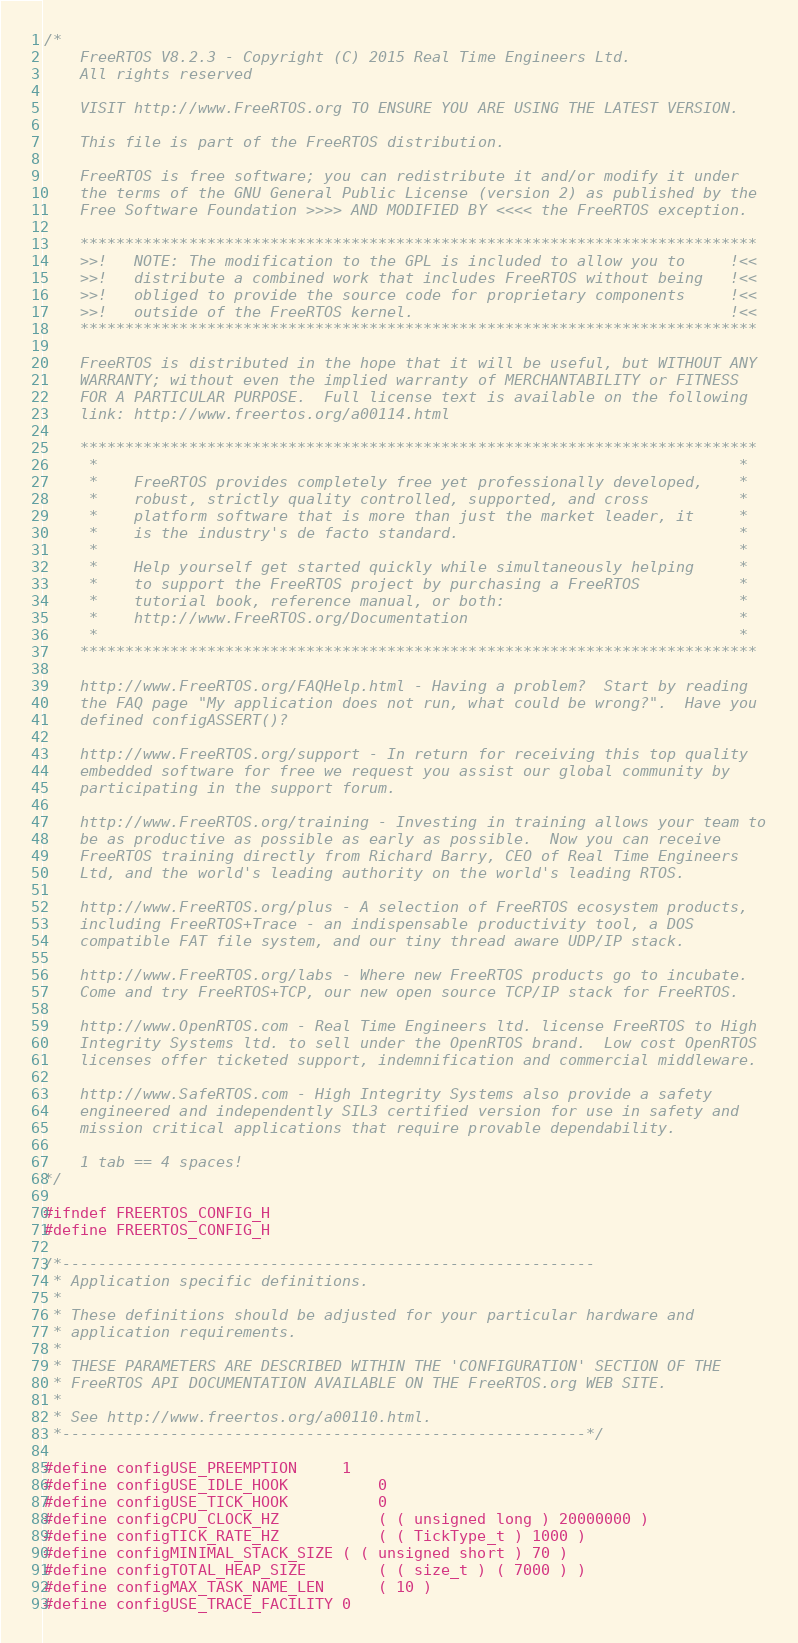<code> <loc_0><loc_0><loc_500><loc_500><_C_>/*
    FreeRTOS V8.2.3 - Copyright (C) 2015 Real Time Engineers Ltd.
    All rights reserved

    VISIT http://www.FreeRTOS.org TO ENSURE YOU ARE USING THE LATEST VERSION.

    This file is part of the FreeRTOS distribution.

    FreeRTOS is free software; you can redistribute it and/or modify it under
    the terms of the GNU General Public License (version 2) as published by the
    Free Software Foundation >>>> AND MODIFIED BY <<<< the FreeRTOS exception.

    ***************************************************************************
    >>!   NOTE: The modification to the GPL is included to allow you to     !<<
    >>!   distribute a combined work that includes FreeRTOS without being   !<<
    >>!   obliged to provide the source code for proprietary components     !<<
    >>!   outside of the FreeRTOS kernel.                                   !<<
    ***************************************************************************

    FreeRTOS is distributed in the hope that it will be useful, but WITHOUT ANY
    WARRANTY; without even the implied warranty of MERCHANTABILITY or FITNESS
    FOR A PARTICULAR PURPOSE.  Full license text is available on the following
    link: http://www.freertos.org/a00114.html

    ***************************************************************************
     *                                                                       *
     *    FreeRTOS provides completely free yet professionally developed,    *
     *    robust, strictly quality controlled, supported, and cross          *
     *    platform software that is more than just the market leader, it     *
     *    is the industry's de facto standard.                               *
     *                                                                       *
     *    Help yourself get started quickly while simultaneously helping     *
     *    to support the FreeRTOS project by purchasing a FreeRTOS           *
     *    tutorial book, reference manual, or both:                          *
     *    http://www.FreeRTOS.org/Documentation                              *
     *                                                                       *
    ***************************************************************************

    http://www.FreeRTOS.org/FAQHelp.html - Having a problem?  Start by reading
    the FAQ page "My application does not run, what could be wrong?".  Have you
    defined configASSERT()?

    http://www.FreeRTOS.org/support - In return for receiving this top quality
    embedded software for free we request you assist our global community by
    participating in the support forum.

    http://www.FreeRTOS.org/training - Investing in training allows your team to
    be as productive as possible as early as possible.  Now you can receive
    FreeRTOS training directly from Richard Barry, CEO of Real Time Engineers
    Ltd, and the world's leading authority on the world's leading RTOS.

    http://www.FreeRTOS.org/plus - A selection of FreeRTOS ecosystem products,
    including FreeRTOS+Trace - an indispensable productivity tool, a DOS
    compatible FAT file system, and our tiny thread aware UDP/IP stack.

    http://www.FreeRTOS.org/labs - Where new FreeRTOS products go to incubate.
    Come and try FreeRTOS+TCP, our new open source TCP/IP stack for FreeRTOS.

    http://www.OpenRTOS.com - Real Time Engineers ltd. license FreeRTOS to High
    Integrity Systems ltd. to sell under the OpenRTOS brand.  Low cost OpenRTOS
    licenses offer ticketed support, indemnification and commercial middleware.

    http://www.SafeRTOS.com - High Integrity Systems also provide a safety
    engineered and independently SIL3 certified version for use in safety and
    mission critical applications that require provable dependability.

    1 tab == 4 spaces!
*/

#ifndef FREERTOS_CONFIG_H
#define FREERTOS_CONFIG_H

/*-----------------------------------------------------------
 * Application specific definitions.
 *
 * These definitions should be adjusted for your particular hardware and
 * application requirements.
 *
 * THESE PARAMETERS ARE DESCRIBED WITHIN THE 'CONFIGURATION' SECTION OF THE
 * FreeRTOS API DOCUMENTATION AVAILABLE ON THE FreeRTOS.org WEB SITE. 
 *
 * See http://www.freertos.org/a00110.html.
 *----------------------------------------------------------*/

#define configUSE_PREEMPTION		1
#define configUSE_IDLE_HOOK			0
#define configUSE_TICK_HOOK			0
#define configCPU_CLOCK_HZ			( ( unsigned long ) 20000000 )
#define configTICK_RATE_HZ			( ( TickType_t ) 1000 )
#define configMINIMAL_STACK_SIZE	( ( unsigned short ) 70 )
#define configTOTAL_HEAP_SIZE		( ( size_t ) ( 7000 ) )
#define configMAX_TASK_NAME_LEN		( 10 )
#define configUSE_TRACE_FACILITY	0</code> 